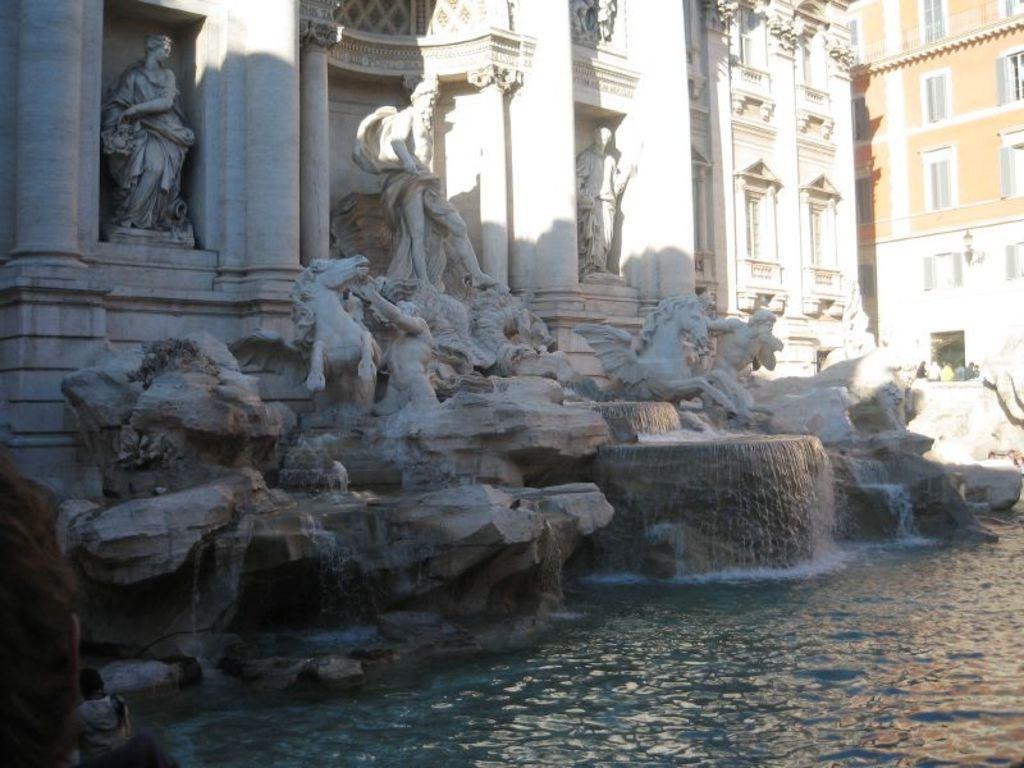Could you give a brief overview of what you see in this image? In this image there are buildings. At the bottom there are sculptures and we can see a fountain. There is water and we can see people. 